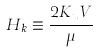<formula> <loc_0><loc_0><loc_500><loc_500>H _ { k } \equiv \frac { 2 K _ { u } V } { \mu }</formula> 